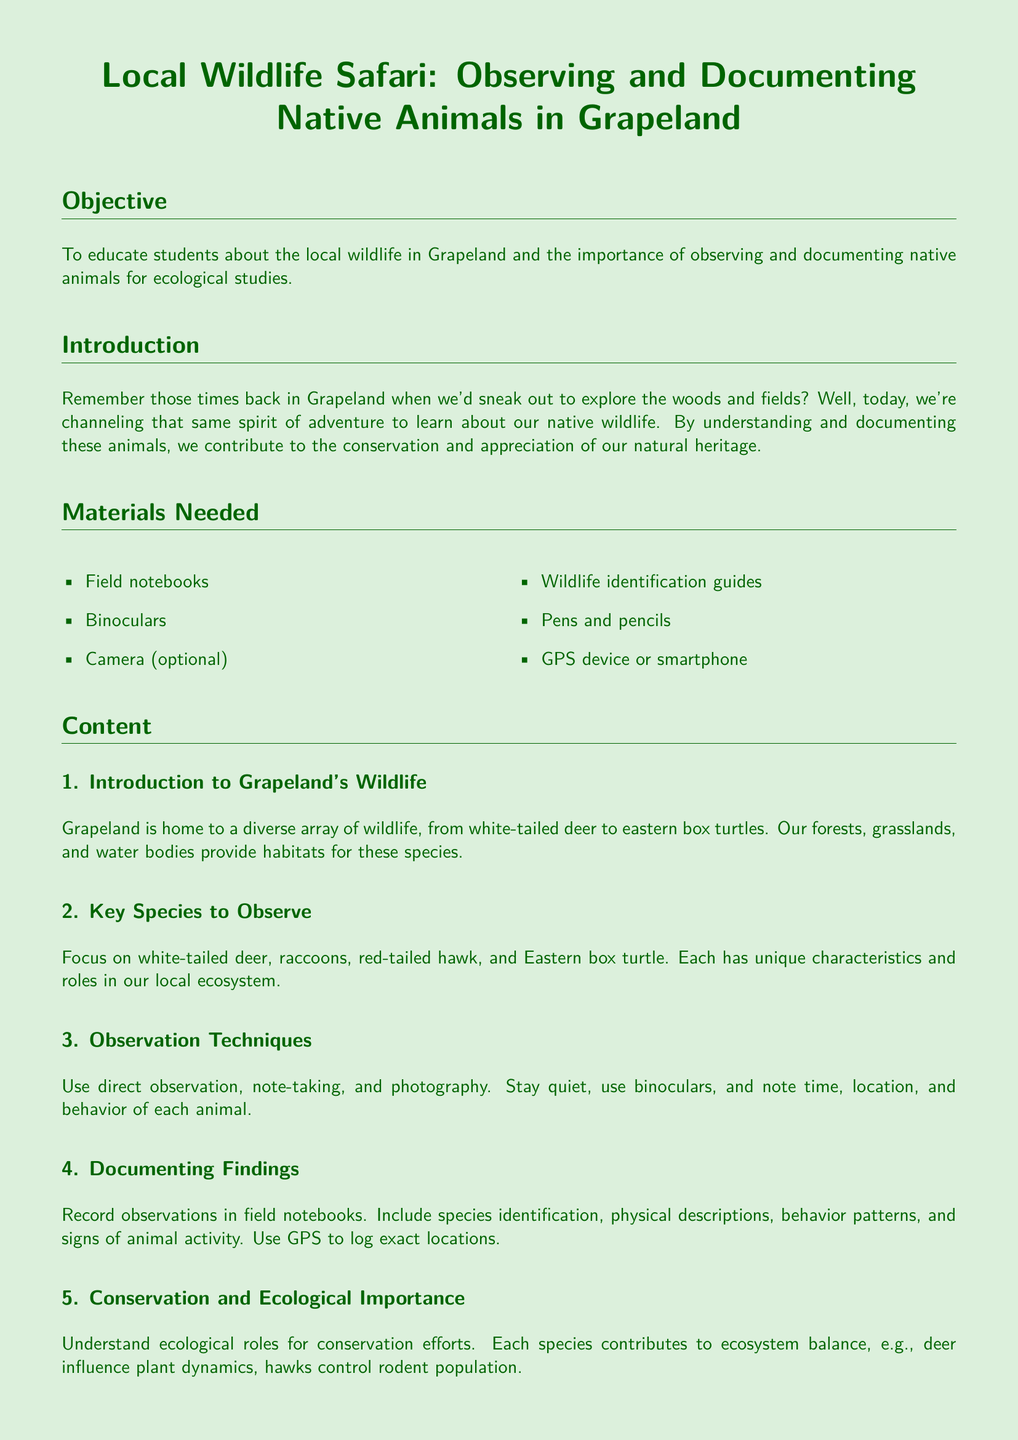What is the objective of the lesson plan? The objective outlines the purpose of the lesson, which is to educate students about local wildlife and the importance of observing and documenting native animals.
Answer: To educate students about the local wildlife in Grapeland and the importance of observing and documenting native animals for ecological studies What materials are needed for the wildlife safari? The materials needed for the activity are listed in the 'Materials Needed' section of the document.
Answer: Field notebooks, binoculars, camera (optional), wildlife identification guides, pens and pencils, GPS device or smartphone Name one animal that students should focus on observing. The document lists several key species under the 'Key Species to Observe' section, providing options for observation.
Answer: White-tailed deer What observation technique involves staying quiet and using binoculars? This question refers specifically to one of the observation techniques described in the 'Observation Techniques' section.
Answer: Direct observation What is one reason why conservation is important according to the document? The document explains the ecological roles of each species, which ties into their importance for conservation efforts.
Answer: Each species contributes to ecosystem balance How many activities are listed in the lesson plan? The number of activities can be counted from the 'Activities' section in the document.
Answer: Three What type of discussion is included in the activities? The content describes a specific kind of discussion that will take place based on the observations collected.
Answer: Discussion on conservation What is the central theme of the conclusion? The conclusion wraps up the themes of curiosity and responsibility in observing wildlife, reflecting on the earlier discussions in the document.
Answer: Combining childhood curiosity with scientific observation techniques What does the document say Grapeland is home to? This is a retrieval question that asks for a general description of the wildlife habitat mentioned in the content.
Answer: A diverse array of wildlife 